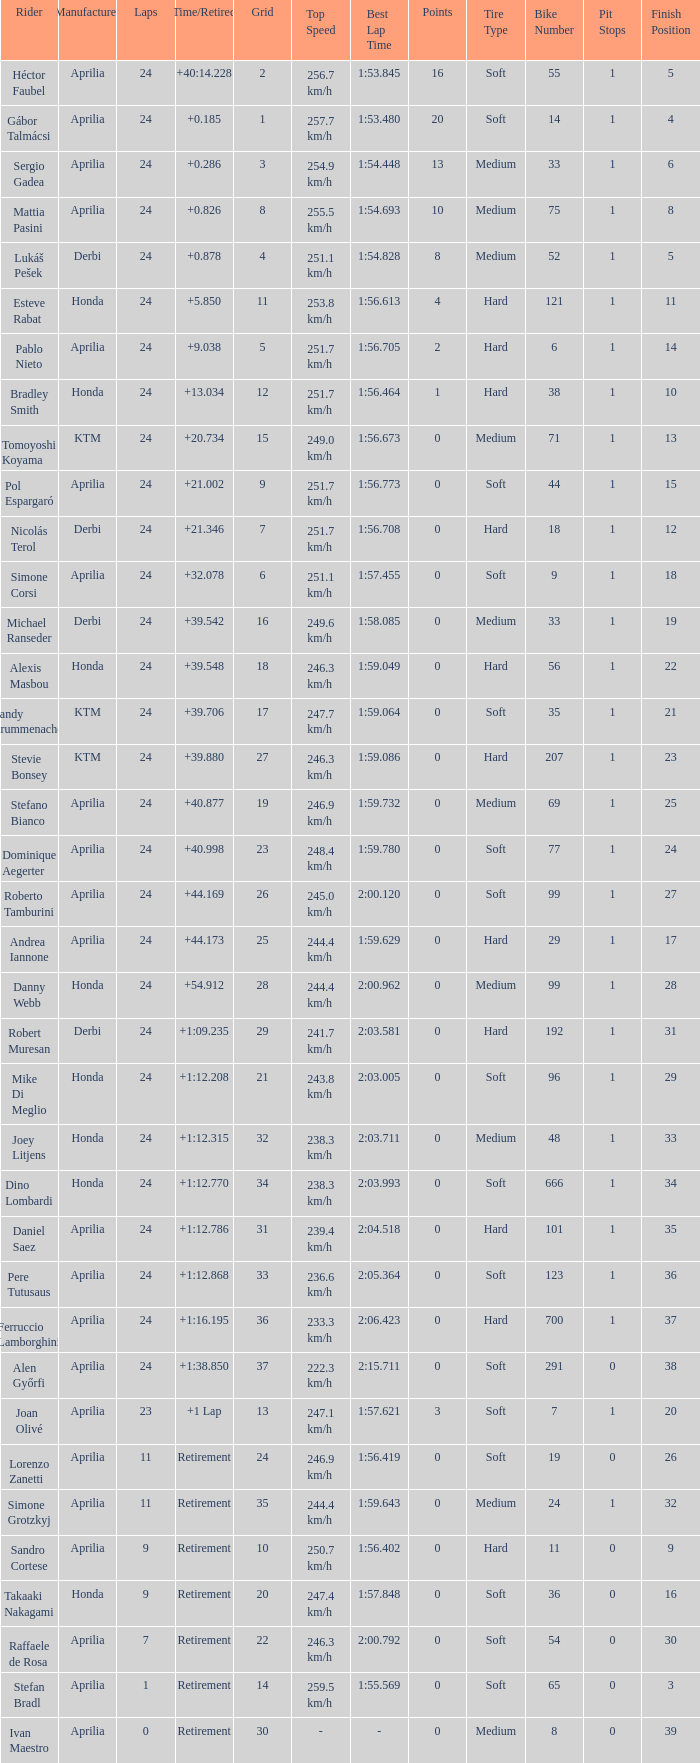Who manufactured the motorcycle that did 24 laps and 9 grids? Aprilia. Can you parse all the data within this table? {'header': ['Rider', 'Manufacturer', 'Laps', 'Time/Retired', 'Grid', 'Top Speed', 'Best Lap Time', 'Points', 'Tire Type', 'Bike Number', 'Pit Stops', 'Finish Position'], 'rows': [['Héctor Faubel', 'Aprilia', '24', '+40:14.228', '2', '256.7 km/h', '1:53.845', '16', 'Soft', '55', '1', '5'], ['Gábor Talmácsi', 'Aprilia', '24', '+0.185', '1', '257.7 km/h', '1:53.480', '20', 'Soft', '14', '1', '4'], ['Sergio Gadea', 'Aprilia', '24', '+0.286', '3', '254.9 km/h', '1:54.448', '13', 'Medium', '33', '1', '6'], ['Mattia Pasini', 'Aprilia', '24', '+0.826', '8', '255.5 km/h', '1:54.693', '10', 'Medium', '75', '1', '8'], ['Lukáš Pešek', 'Derbi', '24', '+0.878', '4', '251.1 km/h', '1:54.828', '8', 'Medium', '52', '1', '5'], ['Esteve Rabat', 'Honda', '24', '+5.850', '11', '253.8 km/h', '1:56.613', '4', 'Hard', '121', '1', '11'], ['Pablo Nieto', 'Aprilia', '24', '+9.038', '5', '251.7 km/h', '1:56.705', '2', 'Hard', '6', '1', '14'], ['Bradley Smith', 'Honda', '24', '+13.034', '12', '251.7 km/h', '1:56.464', '1', 'Hard', '38', '1', '10'], ['Tomoyoshi Koyama', 'KTM', '24', '+20.734', '15', '249.0 km/h', '1:56.673', '0', 'Medium', '71', '1', '13'], ['Pol Espargaró', 'Aprilia', '24', '+21.002', '9', '251.7 km/h', '1:56.773', '0', 'Soft', '44', '1', '15'], ['Nicolás Terol', 'Derbi', '24', '+21.346', '7', '251.7 km/h', '1:56.708', '0', 'Hard', '18', '1', '12'], ['Simone Corsi', 'Aprilia', '24', '+32.078', '6', '251.1 km/h', '1:57.455', '0', 'Soft', '9', '1', '18'], ['Michael Ranseder', 'Derbi', '24', '+39.542', '16', '249.6 km/h', '1:58.085', '0', 'Medium', '33', '1', '19'], ['Alexis Masbou', 'Honda', '24', '+39.548', '18', '246.3 km/h', '1:59.049', '0', 'Hard', '56', '1', '22'], ['Randy Krummenacher', 'KTM', '24', '+39.706', '17', '247.7 km/h', '1:59.064', '0', 'Soft', '35', '1', '21'], ['Stevie Bonsey', 'KTM', '24', '+39.880', '27', '246.3 km/h', '1:59.086', '0', 'Hard', '207', '1', '23'], ['Stefano Bianco', 'Aprilia', '24', '+40.877', '19', '246.9 km/h', '1:59.732', '0', 'Medium', '69', '1', '25'], ['Dominique Aegerter', 'Aprilia', '24', '+40.998', '23', '248.4 km/h', '1:59.780', '0', 'Soft', '77', '1', '24'], ['Roberto Tamburini', 'Aprilia', '24', '+44.169', '26', '245.0 km/h', '2:00.120', '0', 'Soft', '99', '1', '27'], ['Andrea Iannone', 'Aprilia', '24', '+44.173', '25', '244.4 km/h', '1:59.629', '0', 'Hard', '29', '1', '17'], ['Danny Webb', 'Honda', '24', '+54.912', '28', '244.4 km/h', '2:00.962', '0', 'Medium', '99', '1', '28'], ['Robert Muresan', 'Derbi', '24', '+1:09.235', '29', '241.7 km/h', '2:03.581', '0', 'Hard', '192', '1', '31'], ['Mike Di Meglio', 'Honda', '24', '+1:12.208', '21', '243.8 km/h', '2:03.005', '0', 'Soft', '96', '1', '29'], ['Joey Litjens', 'Honda', '24', '+1:12.315', '32', '238.3 km/h', '2:03.711', '0', 'Medium', '48', '1', '33'], ['Dino Lombardi', 'Honda', '24', '+1:12.770', '34', '238.3 km/h', '2:03.993', '0', 'Soft', '666', '1', '34'], ['Daniel Saez', 'Aprilia', '24', '+1:12.786', '31', '239.4 km/h', '2:04.518', '0', 'Hard', '101', '1', '35'], ['Pere Tutusaus', 'Aprilia', '24', '+1:12.868', '33', '236.6 km/h', '2:05.364', '0', 'Soft', '123', '1', '36'], ['Ferruccio Lamborghini', 'Aprilia', '24', '+1:16.195', '36', '233.3 km/h', '2:06.423', '0', 'Hard', '700', '1', '37'], ['Alen Győrfi', 'Aprilia', '24', '+1:38.850', '37', '222.3 km/h', '2:15.711', '0', 'Soft', '291', '0', '38'], ['Joan Olivé', 'Aprilia', '23', '+1 Lap', '13', '247.1 km/h', '1:57.621', '3', 'Soft', '7', '1', '20'], ['Lorenzo Zanetti', 'Aprilia', '11', 'Retirement', '24', '246.9 km/h', '1:56.419', '0', 'Soft', '19', '0', '26'], ['Simone Grotzkyj', 'Aprilia', '11', 'Retirement', '35', '244.4 km/h', '1:59.643', '0', 'Medium', '24', '1', '32'], ['Sandro Cortese', 'Aprilia', '9', 'Retirement', '10', '250.7 km/h', '1:56.402', '0', 'Hard', '11', '0', '9'], ['Takaaki Nakagami', 'Honda', '9', 'Retirement', '20', '247.4 km/h', '1:57.848', '0', 'Soft', '36', '0', '16'], ['Raffaele de Rosa', 'Aprilia', '7', 'Retirement', '22', '246.3 km/h', '2:00.792', '0', 'Soft', '54', '0', '30'], ['Stefan Bradl', 'Aprilia', '1', 'Retirement', '14', '259.5 km/h', '1:55.569', '0', 'Soft', '65', '0', '3'], ['Ivan Maestro', 'Aprilia', '0', 'Retirement', '30', '-', '-', '0', 'Medium', '8', '0', '39']]} 